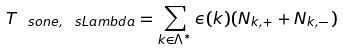Convert formula to latex. <formula><loc_0><loc_0><loc_500><loc_500>T _ { \ s o n e , \ s L a m b d a } = \sum _ { k \in \Lambda ^ { * } } \epsilon ( k ) ( N _ { k , + } + N _ { k , - } )</formula> 